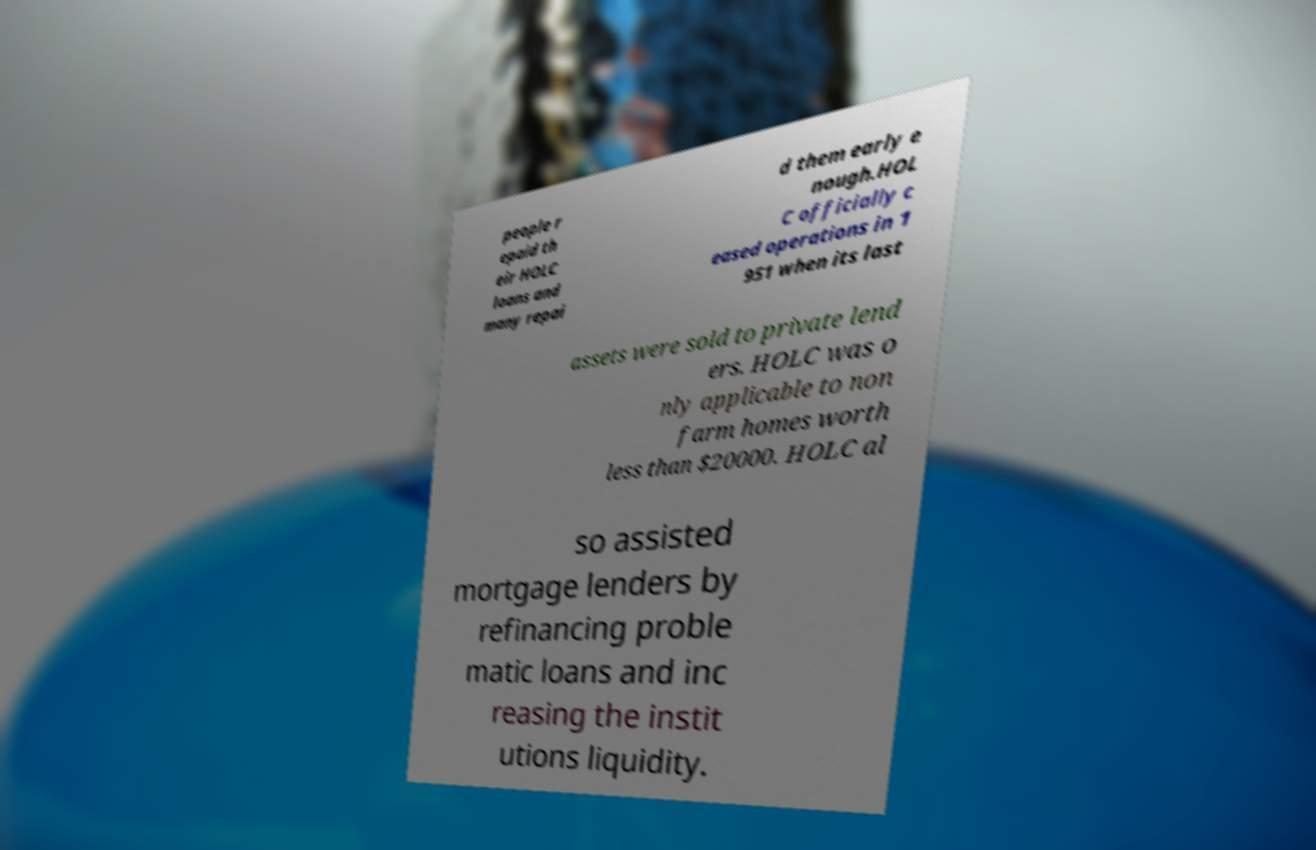Can you accurately transcribe the text from the provided image for me? people r epaid th eir HOLC loans and many repai d them early e nough.HOL C officially c eased operations in 1 951 when its last assets were sold to private lend ers. HOLC was o nly applicable to non farm homes worth less than $20000. HOLC al so assisted mortgage lenders by refinancing proble matic loans and inc reasing the instit utions liquidity. 